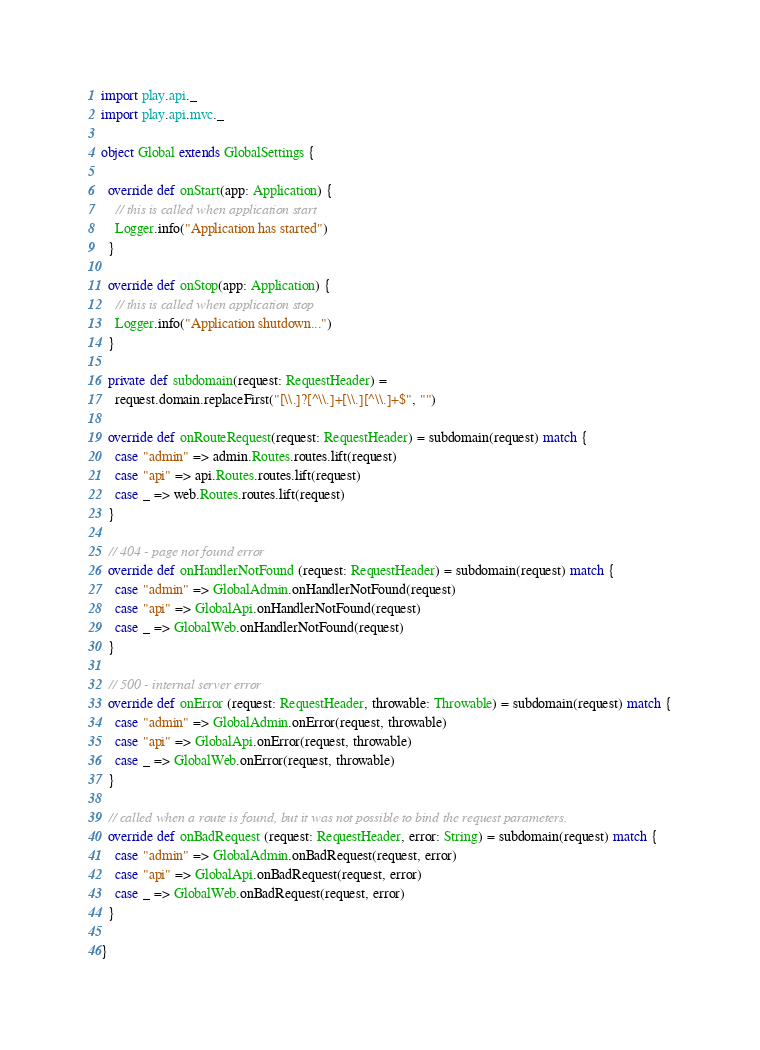<code> <loc_0><loc_0><loc_500><loc_500><_Scala_>import play.api._
import play.api.mvc._

object Global extends GlobalSettings {

  override def onStart(app: Application) {
    // this is called when application start
    Logger.info("Application has started")
  }

  override def onStop(app: Application) {
    // this is called when application stop
    Logger.info("Application shutdown...")
  }

  private def subdomain(request: RequestHeader) =
    request.domain.replaceFirst("[\\.]?[^\\.]+[\\.][^\\.]+$", "")

  override def onRouteRequest(request: RequestHeader) = subdomain(request) match {
    case "admin" => admin.Routes.routes.lift(request)
    case "api" => api.Routes.routes.lift(request)
    case _ => web.Routes.routes.lift(request)
  }

  // 404 - page not found error
  override def onHandlerNotFound (request: RequestHeader) = subdomain(request) match {
    case "admin" => GlobalAdmin.onHandlerNotFound(request)
    case "api" => GlobalApi.onHandlerNotFound(request)
    case _ => GlobalWeb.onHandlerNotFound(request)
  }

  // 500 - internal server error
  override def onError (request: RequestHeader, throwable: Throwable) = subdomain(request) match {
    case "admin" => GlobalAdmin.onError(request, throwable)
    case "api" => GlobalApi.onError(request, throwable)
    case _ => GlobalWeb.onError(request, throwable)
  }

  // called when a route is found, but it was not possible to bind the request parameters.
  override def onBadRequest (request: RequestHeader, error: String) = subdomain(request) match {
    case "admin" => GlobalAdmin.onBadRequest(request, error)
    case "api" => GlobalApi.onBadRequest(request, error)
    case _ => GlobalWeb.onBadRequest(request, error)
  }

}
</code> 